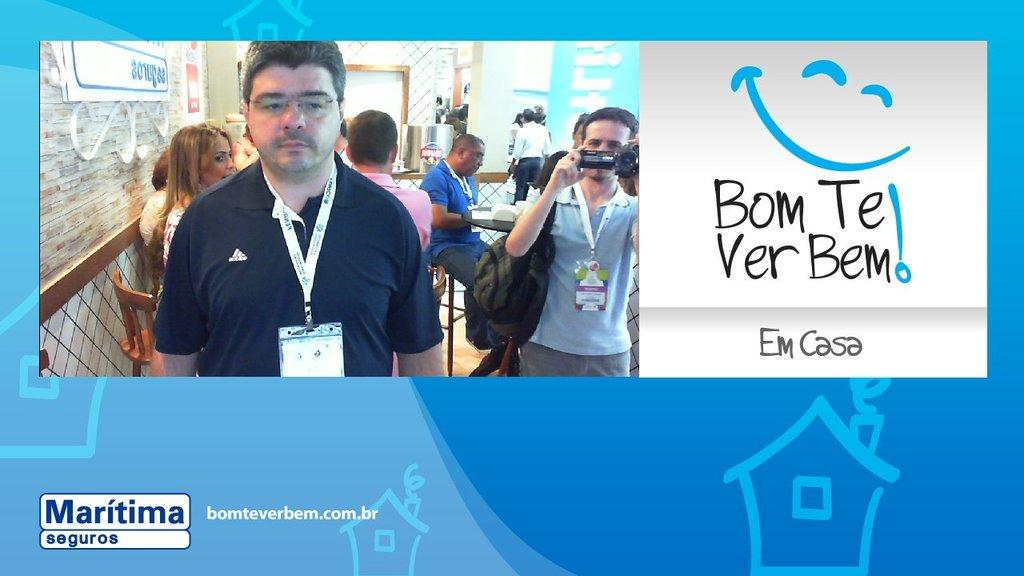What is present in the picture? There is a poster in the picture. What can be seen on the poster? The poster contains an image of people. What type of texture can be felt on the judge's robe in the image? There is no judge or robe present in the image; it only contains a poster with an image of people. 